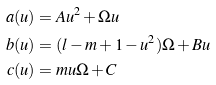<formula> <loc_0><loc_0><loc_500><loc_500>a ( u ) & = A u ^ { 2 } + \Omega u \\ b ( u ) & = ( l - m + 1 - u ^ { 2 } ) \Omega + B u \\ c ( u ) & = m u \Omega + C</formula> 